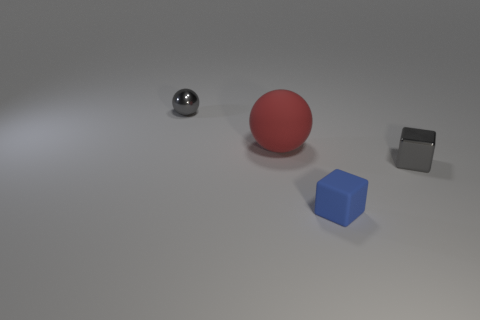Does the shiny ball have the same size as the gray block?
Offer a terse response. Yes. What is the material of the small block on the right side of the matte object that is in front of the tiny block that is behind the rubber cube?
Your response must be concise. Metal. Are there the same number of metal objects left of the red matte object and spheres?
Give a very brief answer. No. Is there anything else that is the same size as the red matte thing?
Give a very brief answer. No. How many objects are balls or big yellow rubber blocks?
Your response must be concise. 2. There is a big red thing that is the same material as the small blue thing; what shape is it?
Give a very brief answer. Sphere. There is a ball that is behind the ball that is on the right side of the tiny gray sphere; how big is it?
Offer a terse response. Small. What number of large things are either blocks or objects?
Ensure brevity in your answer.  1. How many other objects are the same color as the large sphere?
Your answer should be very brief. 0. Is the size of the thing behind the large object the same as the gray metallic thing in front of the tiny metal ball?
Your response must be concise. Yes. 